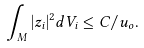<formula> <loc_0><loc_0><loc_500><loc_500>\int _ { M } | z _ { i } | ^ { 2 } d V _ { i } \leq C / u _ { o } .</formula> 